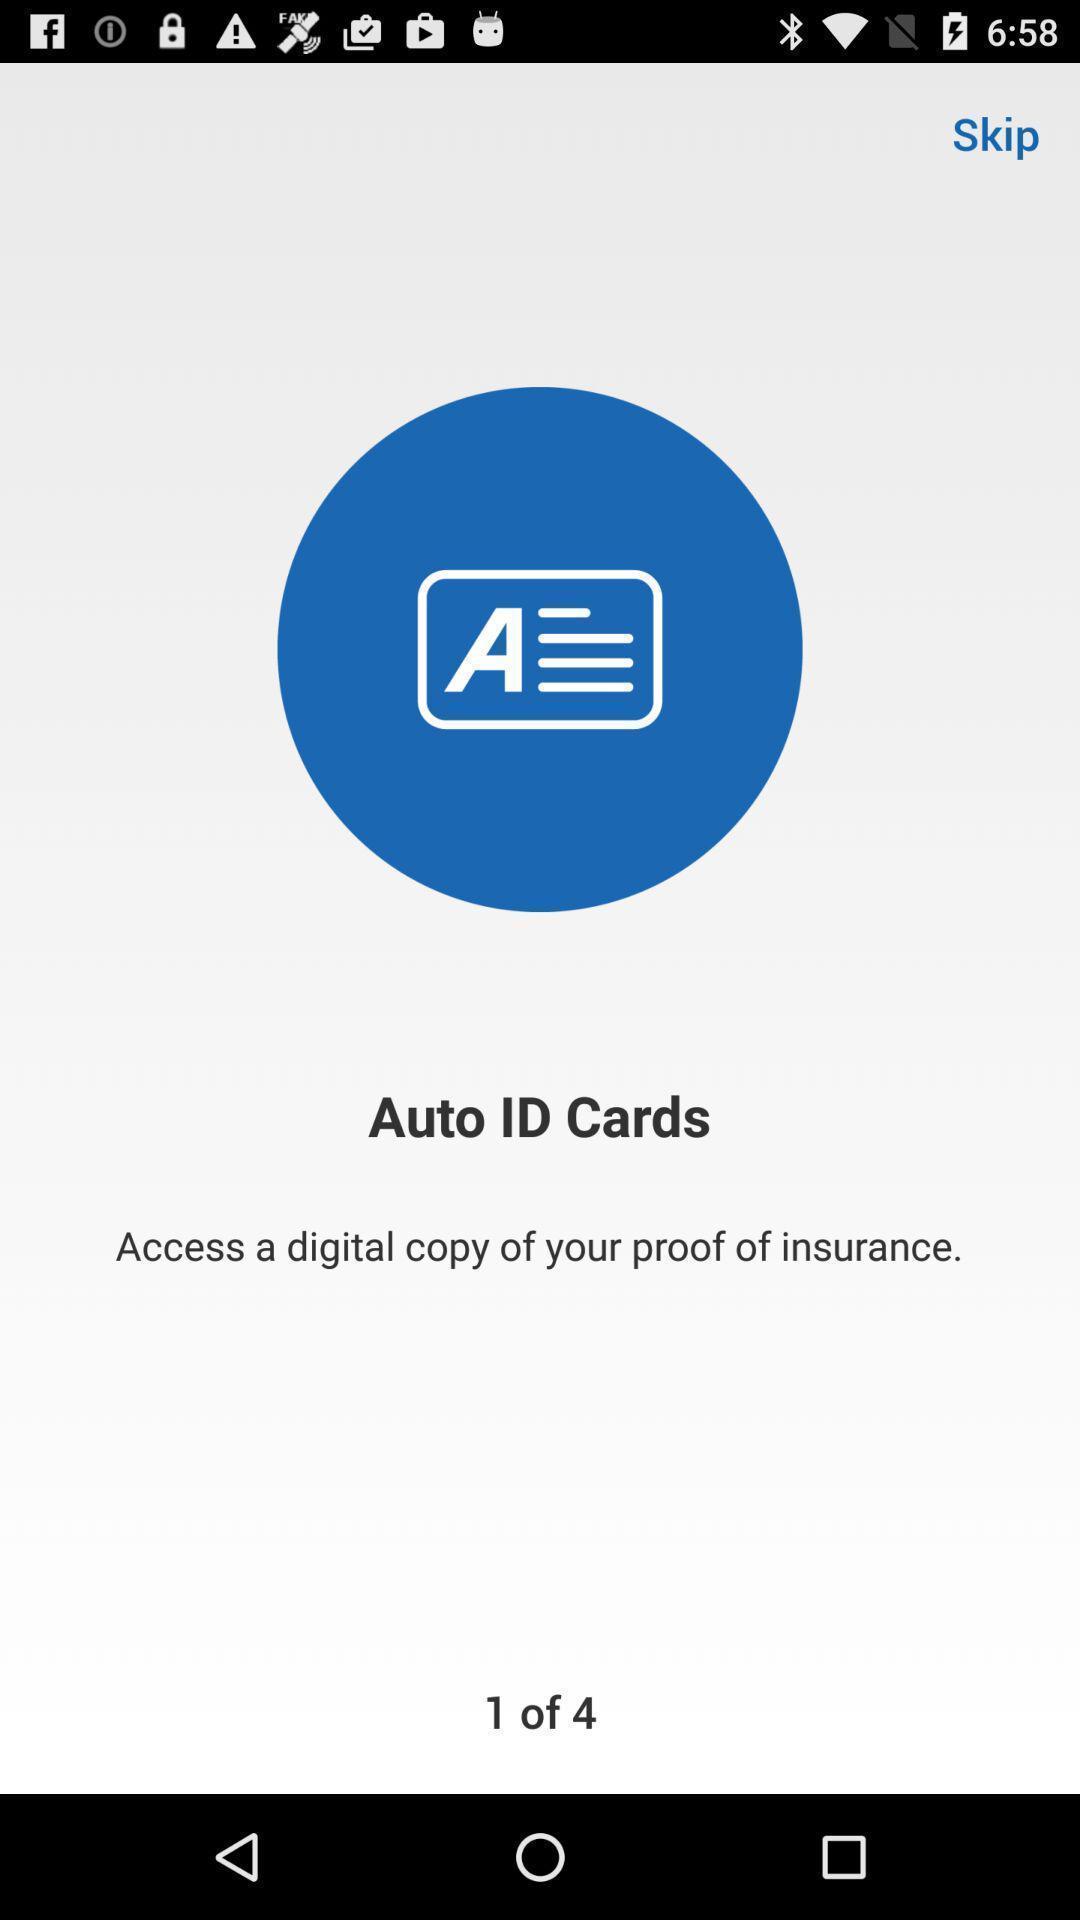Describe the visual elements of this screenshot. Page showing initial pages of a new app. 